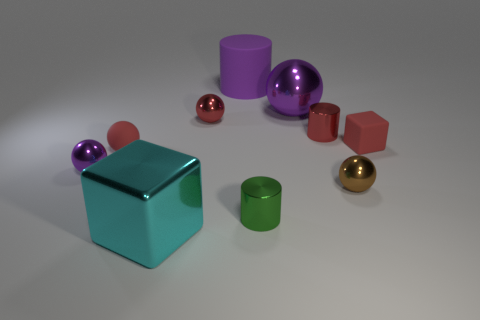What number of tiny red shiny spheres are in front of the small red rubber thing left of the cube to the left of the green metal cylinder?
Provide a short and direct response. 0. There is a metallic cylinder that is behind the small metal sphere left of the large cyan metal object; what size is it?
Make the answer very short. Small. What is the size of the cyan cube that is made of the same material as the small red cylinder?
Ensure brevity in your answer.  Large. What is the shape of the small metallic object that is behind the tiny rubber ball and to the right of the big purple matte cylinder?
Provide a short and direct response. Cylinder. Is the number of rubber cylinders behind the rubber sphere the same as the number of large cyan shiny objects?
Provide a short and direct response. Yes. How many objects are purple spheres or small metal objects in front of the small red cube?
Keep it short and to the point. 4. Are there any other brown objects that have the same shape as the large rubber object?
Provide a succinct answer. No. Is the number of tiny green cylinders in front of the big block the same as the number of large purple rubber objects in front of the big matte cylinder?
Provide a succinct answer. Yes. Is there anything else that is the same size as the red rubber cube?
Your answer should be very brief. Yes. How many yellow things are either metal things or small metallic spheres?
Your answer should be compact. 0. 